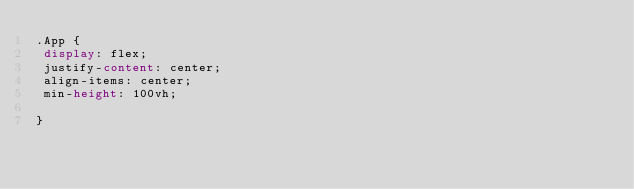Convert code to text. <code><loc_0><loc_0><loc_500><loc_500><_CSS_>.App {
 display: flex; 
 justify-content: center;
 align-items: center;
 min-height: 100vh;

}
</code> 